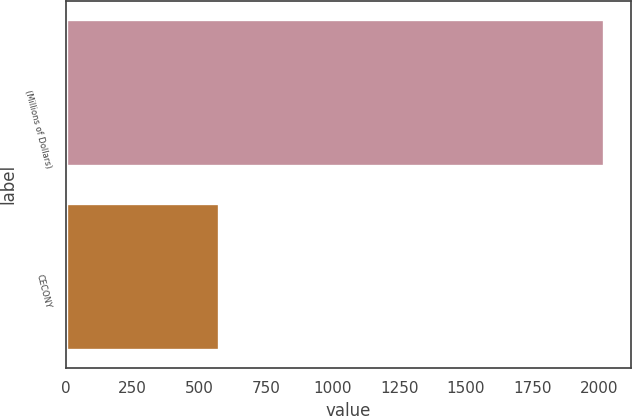<chart> <loc_0><loc_0><loc_500><loc_500><bar_chart><fcel>(Millions of Dollars)<fcel>CECONY<nl><fcel>2016<fcel>574<nl></chart> 